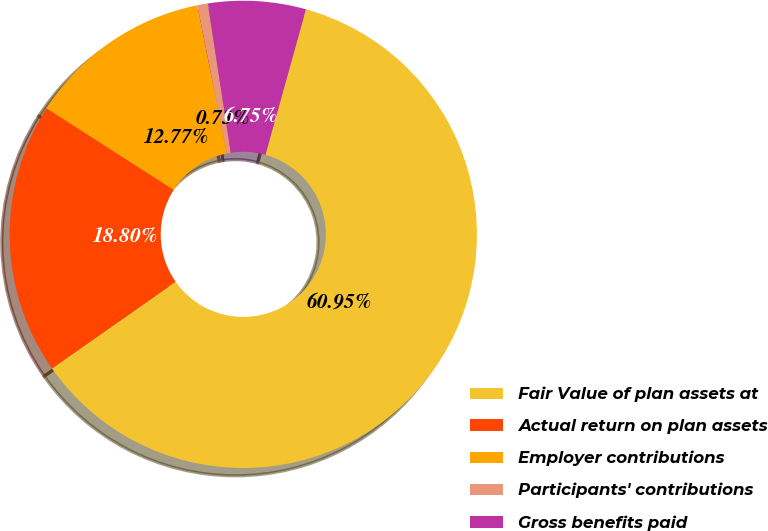<chart> <loc_0><loc_0><loc_500><loc_500><pie_chart><fcel>Fair Value of plan assets at<fcel>Actual return on plan assets<fcel>Employer contributions<fcel>Participants' contributions<fcel>Gross benefits paid<nl><fcel>60.94%<fcel>18.8%<fcel>12.77%<fcel>0.73%<fcel>6.75%<nl></chart> 